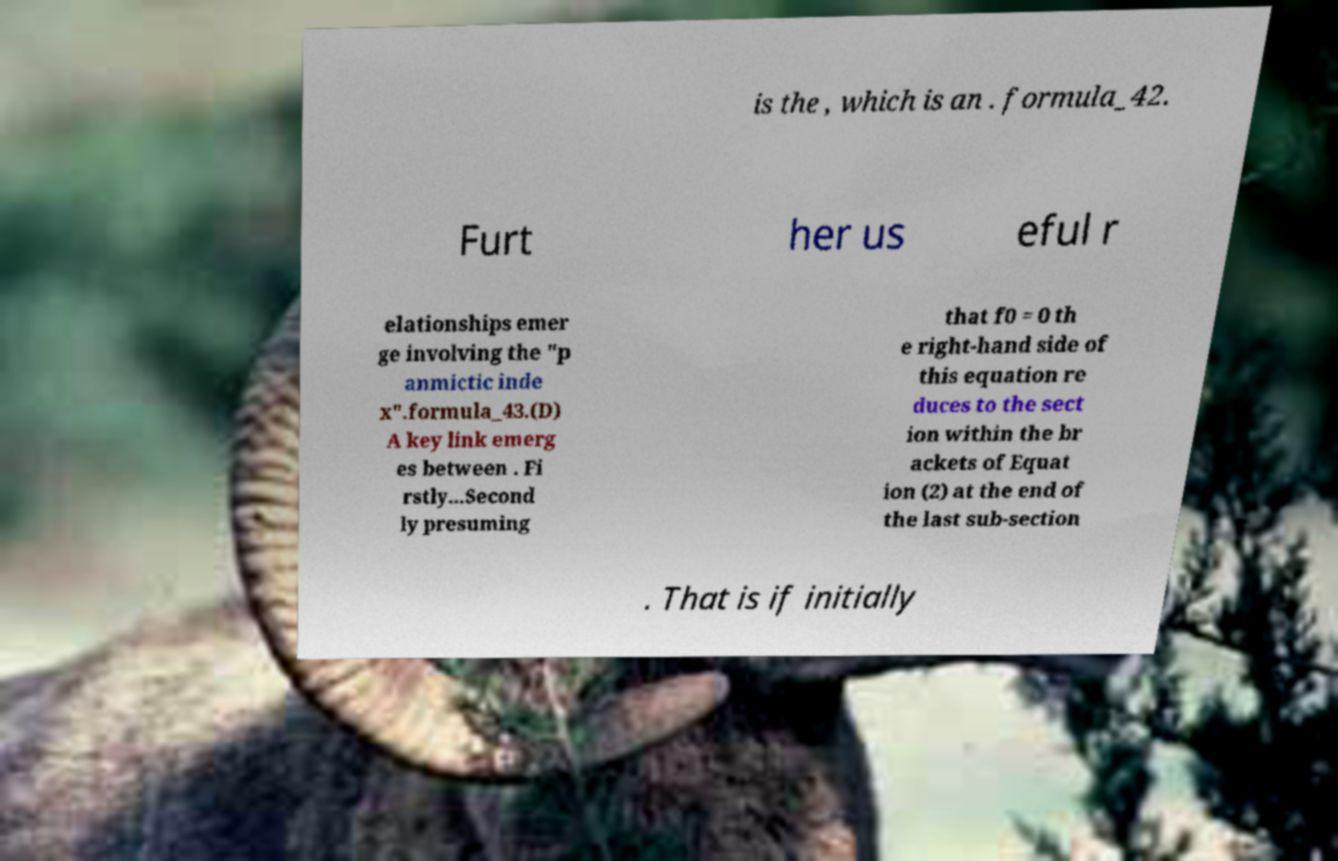Can you read and provide the text displayed in the image?This photo seems to have some interesting text. Can you extract and type it out for me? is the , which is an . formula_42. Furt her us eful r elationships emer ge involving the "p anmictic inde x".formula_43.(D) A key link emerg es between . Fi rstly...Second ly presuming that f0 = 0 th e right-hand side of this equation re duces to the sect ion within the br ackets of Equat ion (2) at the end of the last sub-section . That is if initially 